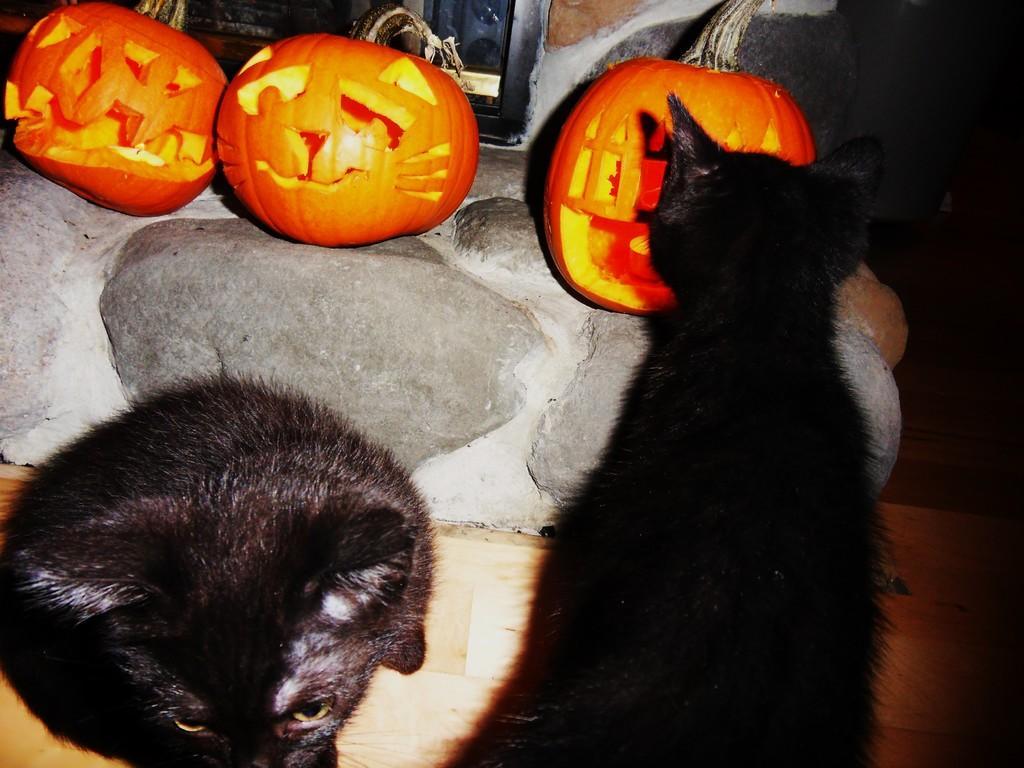Describe this image in one or two sentences. In this image I can see two cats sitting on the floor. They are in black color. Back Side I can see three pumpkins. They are in orange color. 